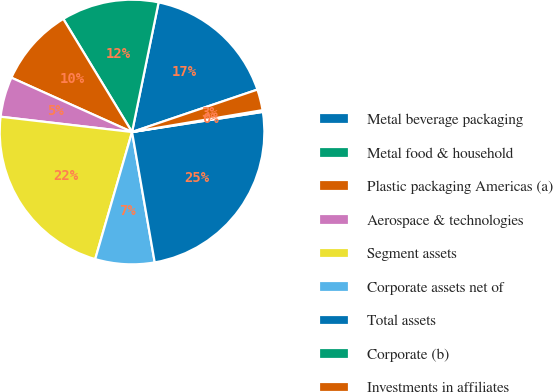Convert chart. <chart><loc_0><loc_0><loc_500><loc_500><pie_chart><fcel>Metal beverage packaging<fcel>Metal food & household<fcel>Plastic packaging Americas (a)<fcel>Aerospace & technologies<fcel>Segment assets<fcel>Corporate assets net of<fcel>Total assets<fcel>Corporate (b)<fcel>Investments in affiliates<nl><fcel>16.59%<fcel>11.91%<fcel>9.57%<fcel>4.89%<fcel>22.35%<fcel>7.23%<fcel>24.69%<fcel>0.21%<fcel>2.55%<nl></chart> 